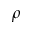<formula> <loc_0><loc_0><loc_500><loc_500>\rho</formula> 